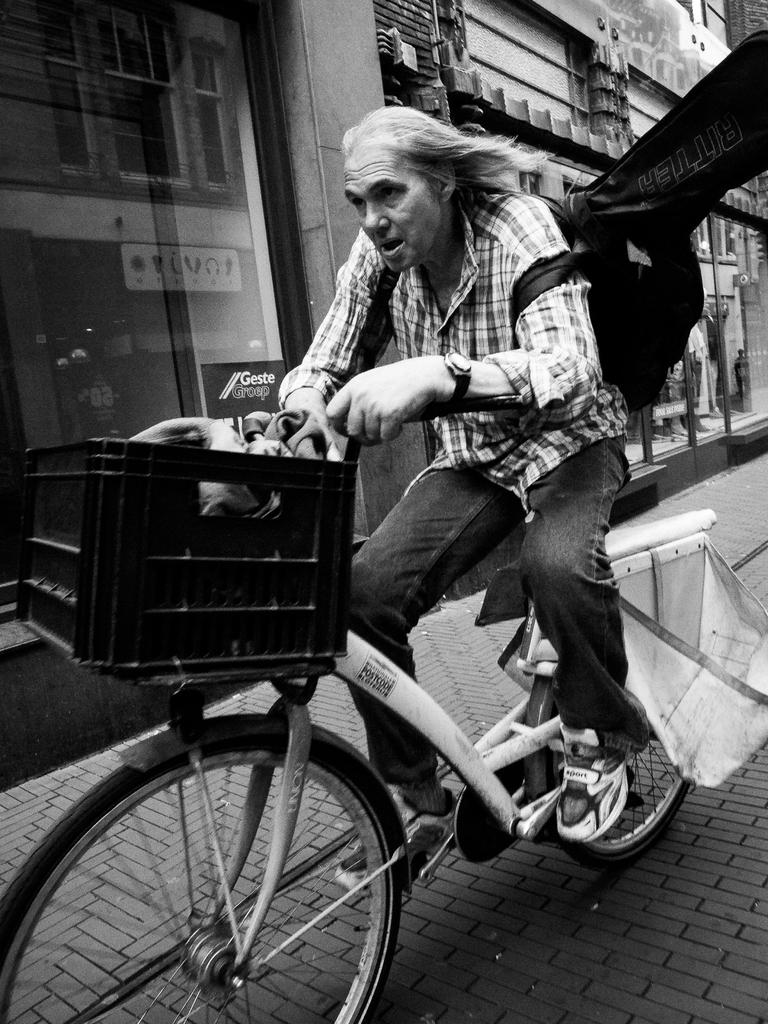Who is the main subject in the image? There is a man in the image. What is the man doing in the image? The man is riding a bicycle. What can be seen in the background of the image? There are buildings in the image. Where is the garden located in the image? There is no garden present in the image. What rule is being enforced by the man in the image? The image does not depict any rules or enforcement; it simply shows a man riding a bicycle. 